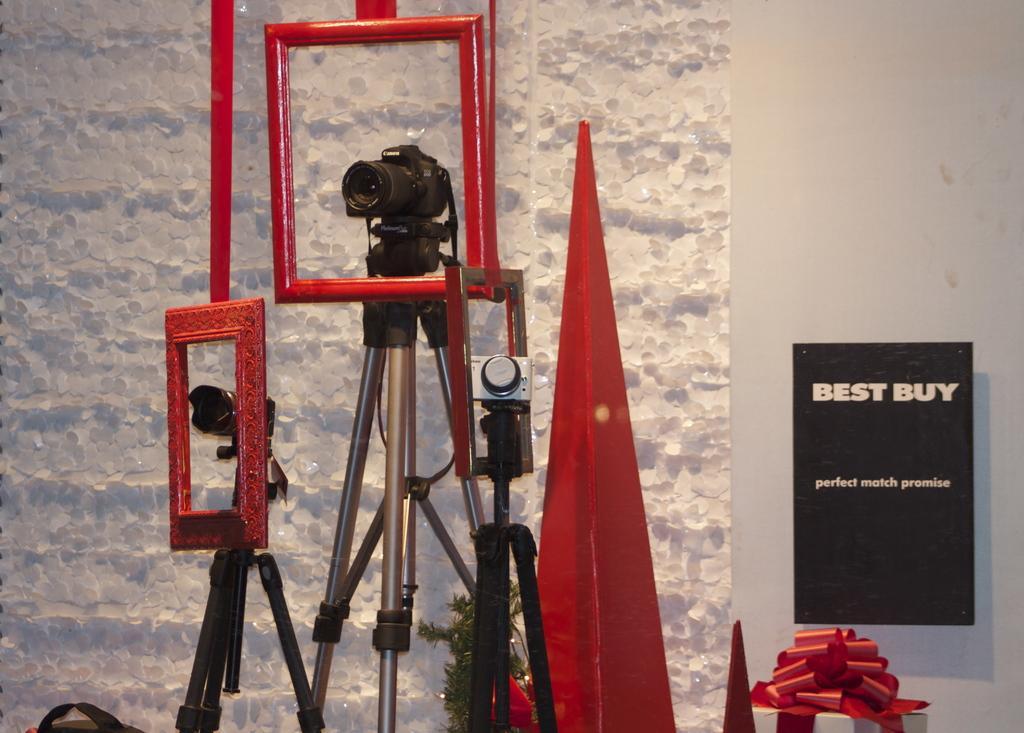Can you describe this image briefly? In this image we can see cameras placed on the stands. In the background there is a wall and we can see a board. We can see a gift and there is a decor. There are frames. 